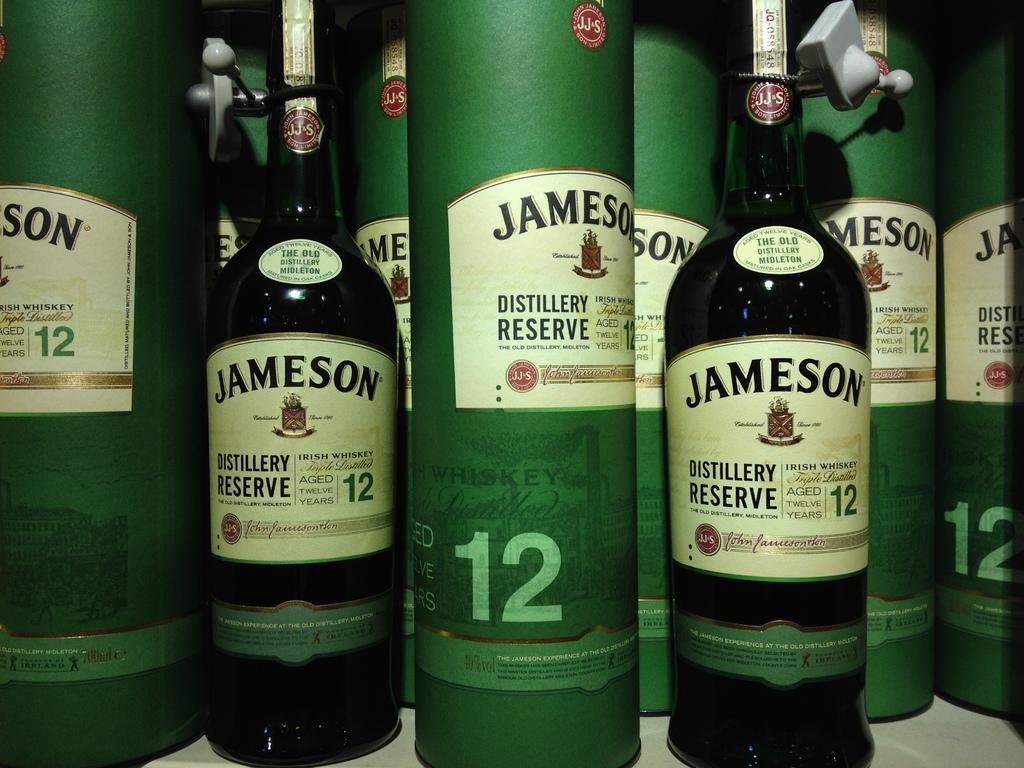Could you give a brief overview of what you see in this image? In this image I can see few wine bottles and few boxes in green color and few stickers are attached it. 